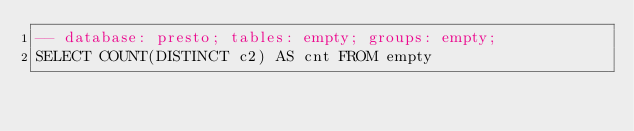<code> <loc_0><loc_0><loc_500><loc_500><_SQL_>-- database: presto; tables: empty; groups: empty;
SELECT COUNT(DISTINCT c2) AS cnt FROM empty
</code> 